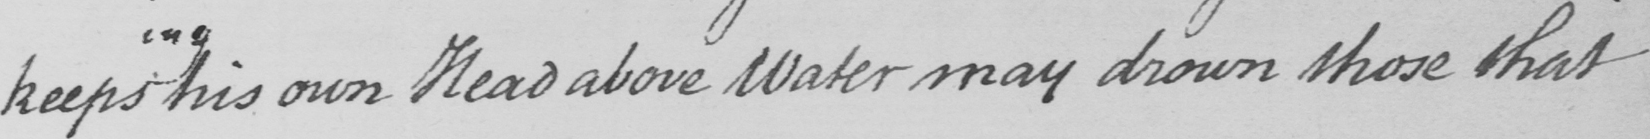Transcribe the text shown in this historical manuscript line. keeps his own Head above Water may drown those that 